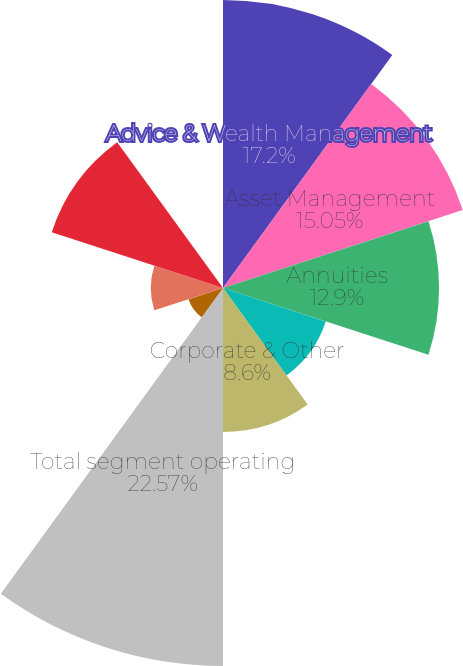Convert chart. <chart><loc_0><loc_0><loc_500><loc_500><pie_chart><fcel>Advice & Wealth Management<fcel>Asset Management<fcel>Annuities<fcel>Protection<fcel>Corporate & Other<fcel>Total segment operating<fcel>Net realized gains<fcel>Net income attributable to<fcel>Market impact on variable<fcel>Market impact on IUL benefits<nl><fcel>17.2%<fcel>15.05%<fcel>12.9%<fcel>6.45%<fcel>8.6%<fcel>22.57%<fcel>2.16%<fcel>4.31%<fcel>10.75%<fcel>0.01%<nl></chart> 